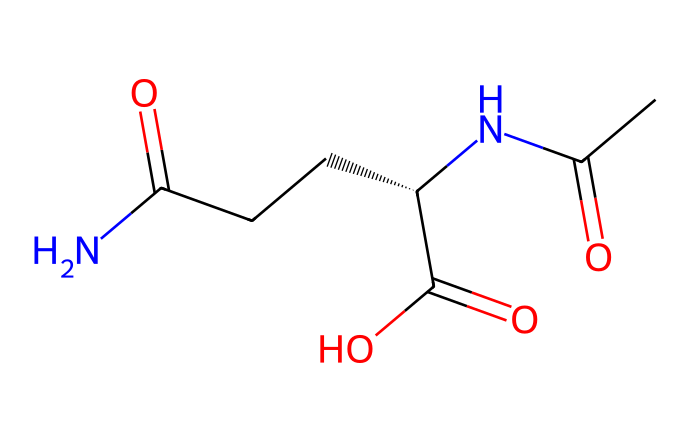What is the molecular formula of L-theanine? By analyzing the structure's components, you can count the atoms: 6 carbon (C), 10 hydrogen (H), 4 nitrogen (N), and 2 oxygen (O). This counts to make the formula C7H14N2O3.
Answer: C7H14N2O3 How many nitrogen atoms are present in L-theanine? The chemical structure reveals two nitrogen atoms, indicated by the N labels in the SMILES representation and its arrangement.
Answer: 2 What type of functional groups are present in L-theanine? By examining the structure, you can identify the presence of an amide (due to the carbonyl adjacent to nitrogen) and a carboxylic acid (due to the -COOH group), which are both characteristic of medicinal compounds.
Answer: amide and carboxylic acid What is the stereochemistry of L-theanine? The SMILES notation has the notation [C@@H], which indicates that there is a chiral center with an 'S' configuration in its stereochemistry, leading to unique interaction properties.
Answer: S What would be the classification of L-theanine based on its effects? L-theanine is classified as a relaxant and anxiolytic based on its chemical structure and how it interacts with neurotransmitters, influencing calming effects.
Answer: relaxant How many carbon-carbon bonds are in L-theanine? The structure can be parsed visually to identify numerous carbon atoms connected to each other, counting a total of five carbon-carbon bonds present in the compound.
Answer: 5 What role does L-theanine primarily play pharmacologically? The chemical structure indicates its primary role as an enhancer of relaxation and focus due to its effects on neurotransmitter levels in the brain.
Answer: enhancer 